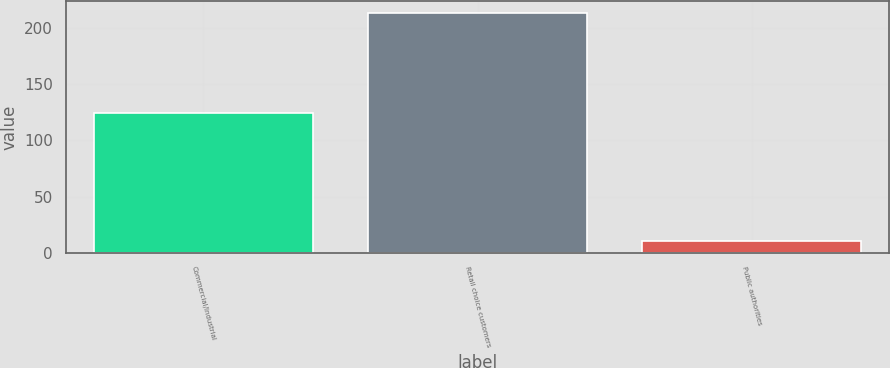<chart> <loc_0><loc_0><loc_500><loc_500><bar_chart><fcel>Commercial/Industrial<fcel>Retail choice customers<fcel>Public authorities<nl><fcel>124<fcel>213<fcel>10<nl></chart> 